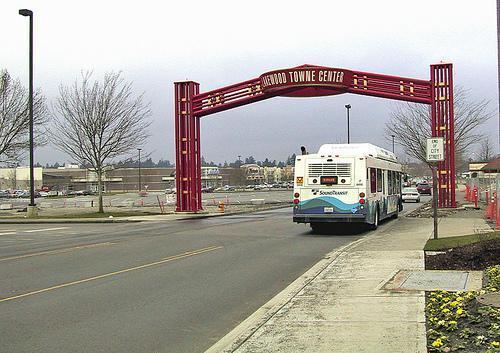How many buses are in the picture?
Give a very brief answer. 1. 